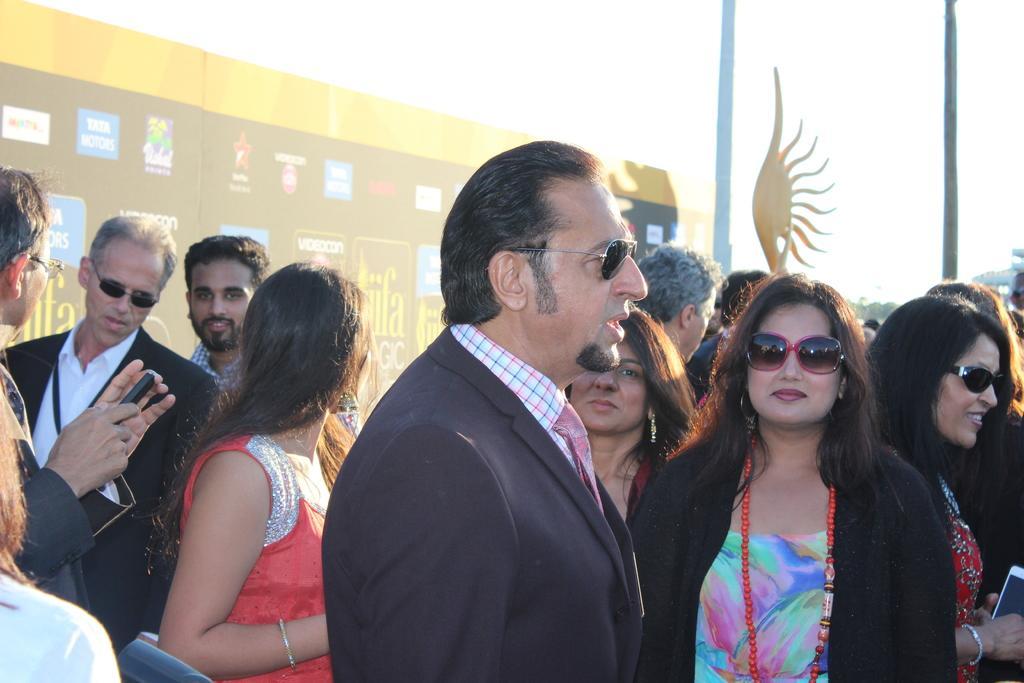Please provide a concise description of this image. In this picture I can see a group of people in the middle, in the background it looks like a banner. At the top there is the sky. 